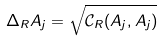Convert formula to latex. <formula><loc_0><loc_0><loc_500><loc_500>\Delta _ { R } A _ { j } = \sqrt { \mathcal { C } _ { R } ( A _ { j } , A _ { j } ) }</formula> 